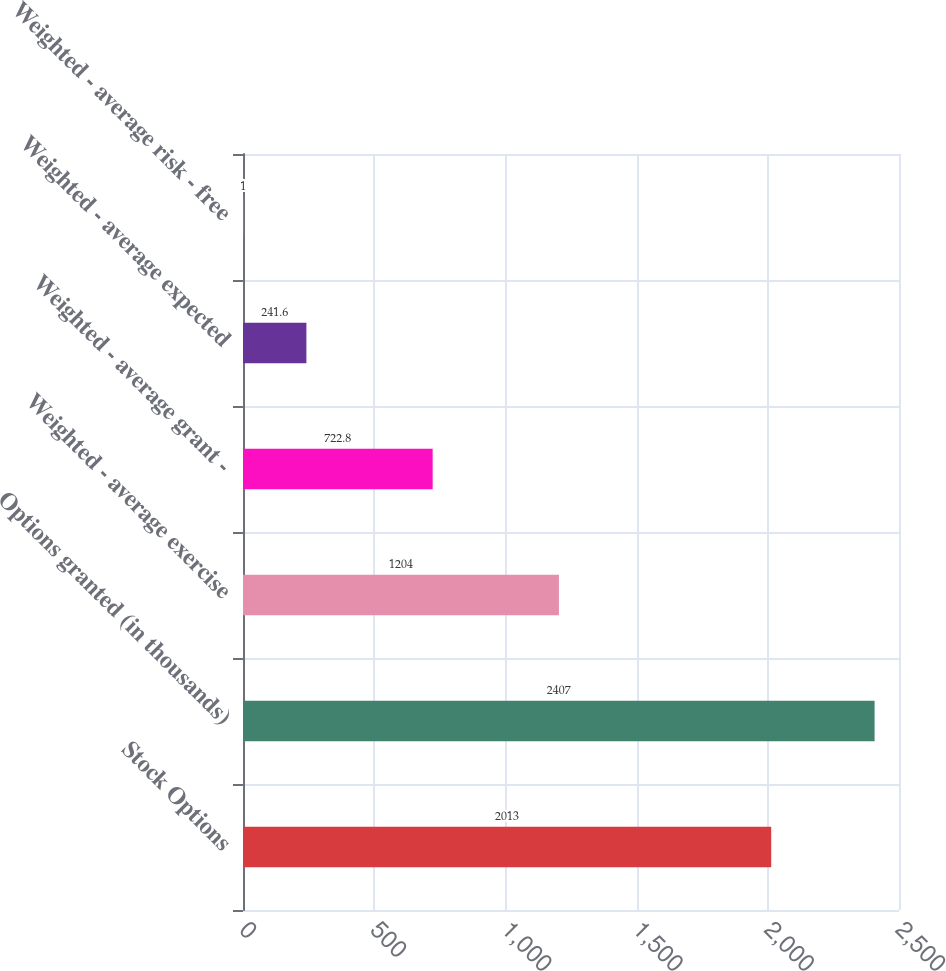Convert chart. <chart><loc_0><loc_0><loc_500><loc_500><bar_chart><fcel>Stock Options<fcel>Options granted (in thousands)<fcel>Weighted - average exercise<fcel>Weighted - average grant -<fcel>Weighted - average expected<fcel>Weighted - average risk - free<nl><fcel>2013<fcel>2407<fcel>1204<fcel>722.8<fcel>241.6<fcel>1<nl></chart> 